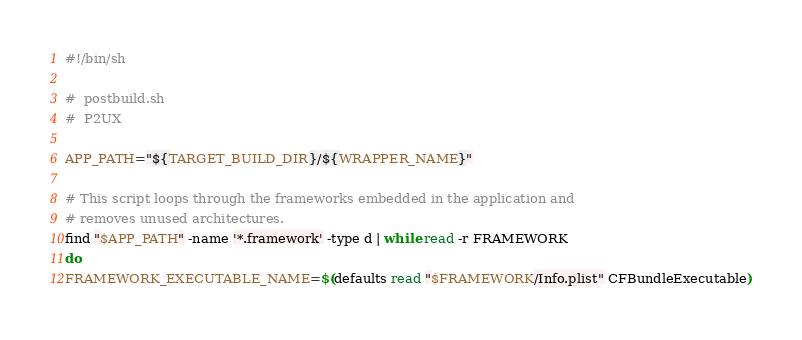<code> <loc_0><loc_0><loc_500><loc_500><_Bash_>#!/bin/sh

#  postbuild.sh
#  P2UX

APP_PATH="${TARGET_BUILD_DIR}/${WRAPPER_NAME}"

# This script loops through the frameworks embedded in the application and
# removes unused architectures.
find "$APP_PATH" -name '*.framework' -type d | while read -r FRAMEWORK
do
FRAMEWORK_EXECUTABLE_NAME=$(defaults read "$FRAMEWORK/Info.plist" CFBundleExecutable)</code> 